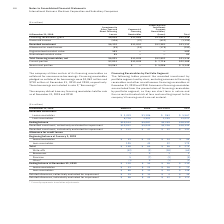According to International Business Machines's financial document, How does the company utilizes certain of its financing receivables? The company utilizes certain of its financing receivables as collateral for nonrecourse borrowings.. The document states: "The company utilizes certain of its financing receivables as collateral for nonrecourse borrowings. Financing receivables pledged as collateral for bo..." Also, What amount of Financing receivables pledged as collateral for borrowings in December 2018 and 2019? Financing receivables pledged as collateral for borrowings were $1,062 million and $710 million at December 31, 2019 and 2018, respectively.. The document states: "eivables as collateral for nonrecourse borrowings. Financing receivables pledged as collateral for borrowings were $1,062 million and $710 million at ..." Also, Did the company have any financing receivables held for sale as of December 2019 and 2018. The company did not have any financing receivables held for sale as of December 31, 2019 and 2018.. The document states: "The company did not have any financing receivables held for sale as of December 31, 2019 and 2018...." Also, can you calculate: What is the average Unearned income? Based on the calculation: 1,195 / 3, the result is 398.33 (in millions). This is based on the information: "Unearned income (526) (37) (632) (1,195) Unearned income (526) (37) (632) (1,195)..." The key data points involved are: 1,195. Also, can you calculate: What is the average Recorded investment? Based on the calculation: 31,153 / 3, the result is 10384.33 (in millions). This is based on the information: "Recorded investment $6,320 $11,852 $12,981 $31,153 Recorded investment $6,320 $11,852 $12,981 $31,153..." The key data points involved are: 31,153. Also, can you calculate: How much is the difference between Unguaranteed and Guaranteed residual value of Investment in Sales-Type and Direct Financing Leases? Based on the calculation: 589-85 , the result is 504 (in millions). This is based on the information: "Unguaranteed residual value 589 — — 589 Guaranteed residual value 85 — — 85..." The key data points involved are: 589, 85. 